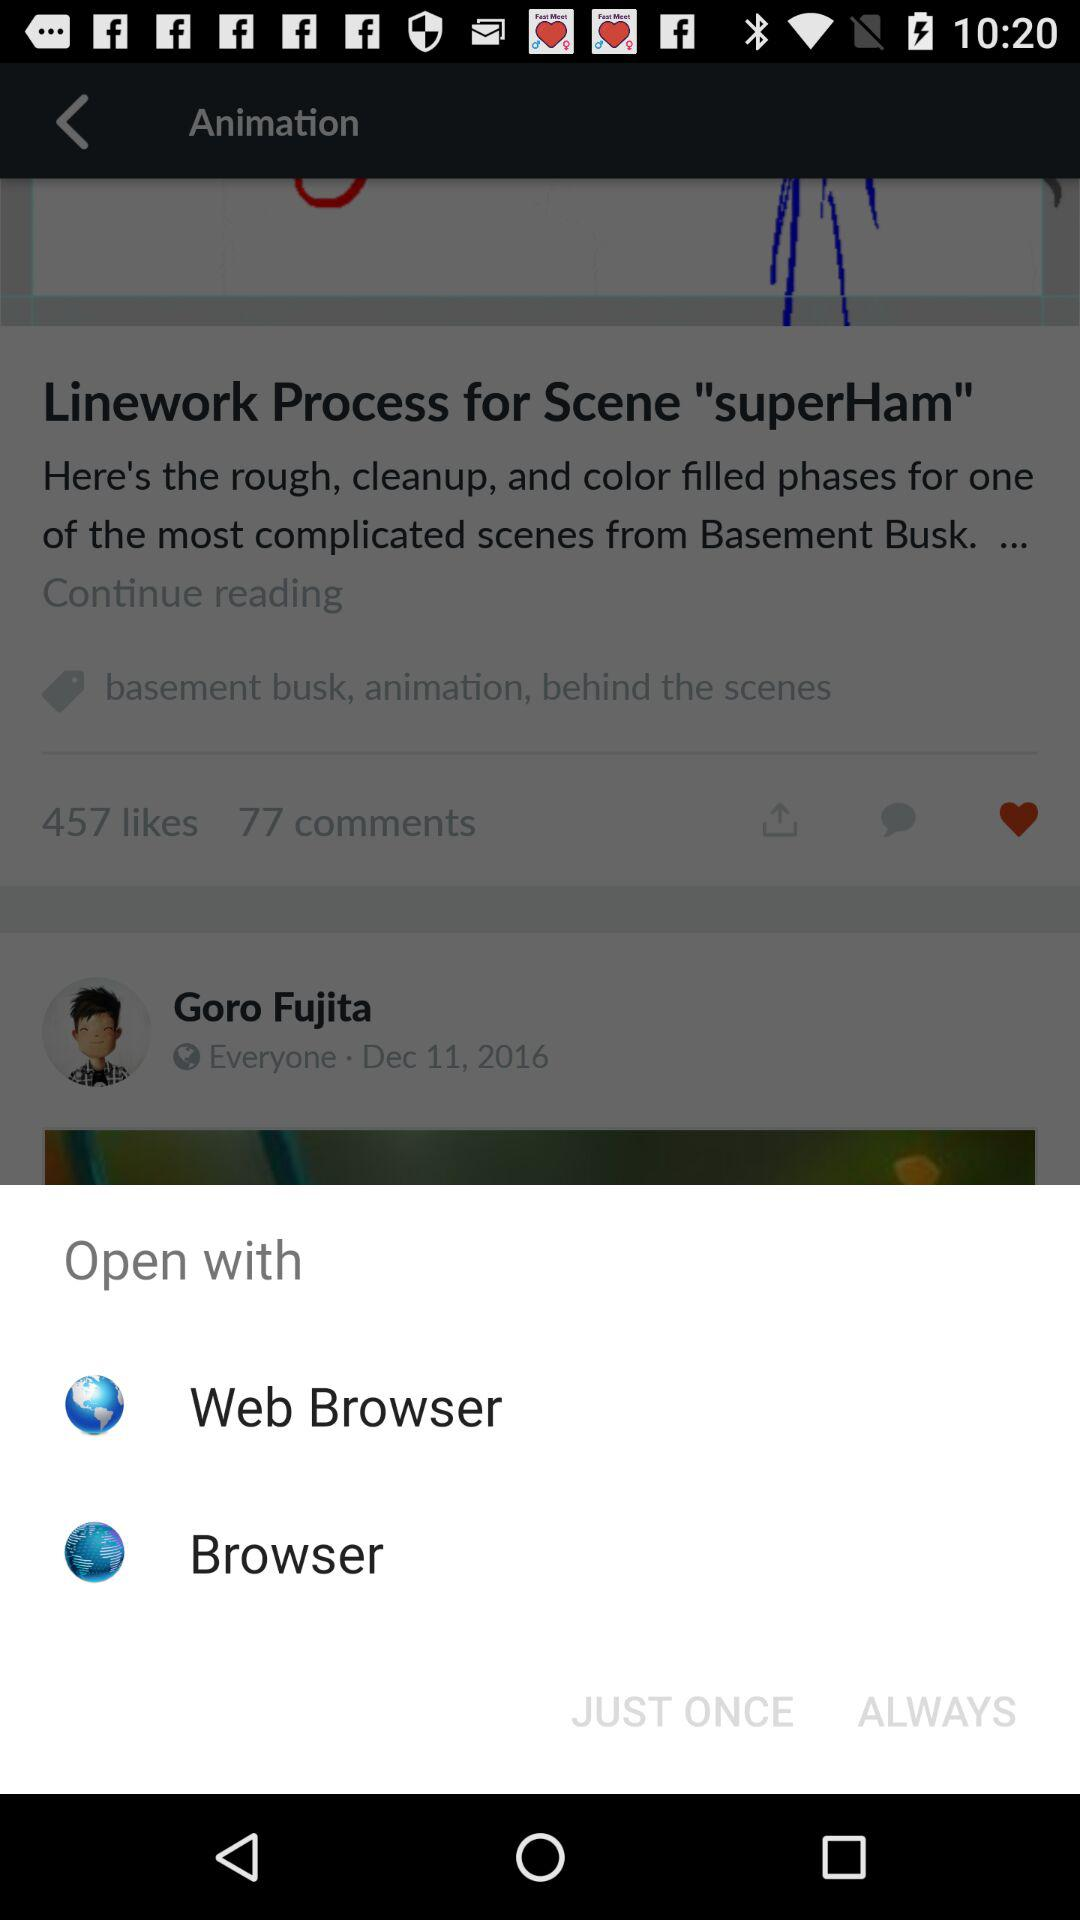How many open with options are there?
Answer the question using a single word or phrase. 2 